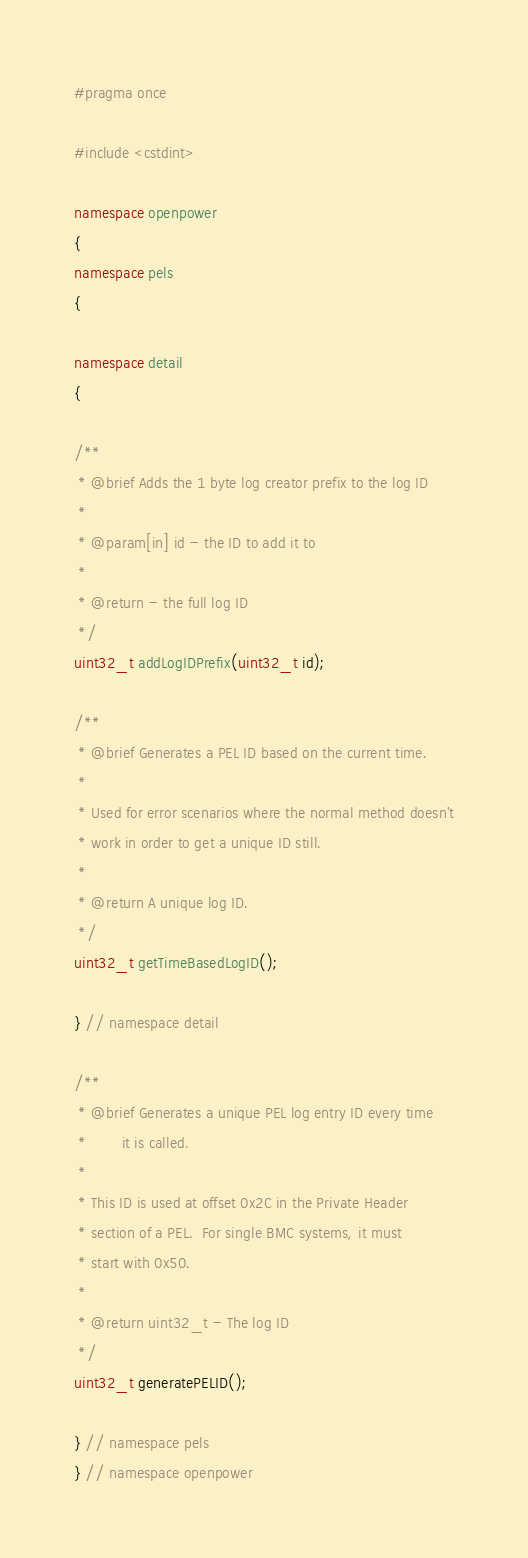Convert code to text. <code><loc_0><loc_0><loc_500><loc_500><_C++_>#pragma once

#include <cstdint>

namespace openpower
{
namespace pels
{

namespace detail
{

/**
 * @brief Adds the 1 byte log creator prefix to the log ID
 *
 * @param[in] id - the ID to add it to
 *
 * @return - the full log ID
 */
uint32_t addLogIDPrefix(uint32_t id);

/**
 * @brief Generates a PEL ID based on the current time.
 *
 * Used for error scenarios where the normal method doesn't
 * work in order to get a unique ID still.
 *
 * @return A unique log ID.
 */
uint32_t getTimeBasedLogID();

} // namespace detail

/**
 * @brief Generates a unique PEL log entry ID every time
 *        it is called.
 *
 * This ID is used at offset 0x2C in the Private Header
 * section of a PEL.  For single BMC systems, it must
 * start with 0x50.
 *
 * @return uint32_t - The log ID
 */
uint32_t generatePELID();

} // namespace pels
} // namespace openpower
</code> 